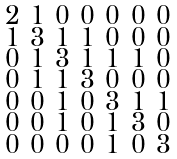<formula> <loc_0><loc_0><loc_500><loc_500>\begin{smallmatrix} 2 & 1 & 0 & 0 & 0 & 0 & 0 \\ 1 & 3 & 1 & 1 & 0 & 0 & 0 \\ 0 & 1 & 3 & 1 & 1 & 1 & 0 \\ 0 & 1 & 1 & 3 & 0 & 0 & 0 \\ 0 & 0 & 1 & 0 & 3 & 1 & 1 \\ 0 & 0 & 1 & 0 & 1 & 3 & 0 \\ 0 & 0 & 0 & 0 & 1 & 0 & 3 \end{smallmatrix}</formula> 